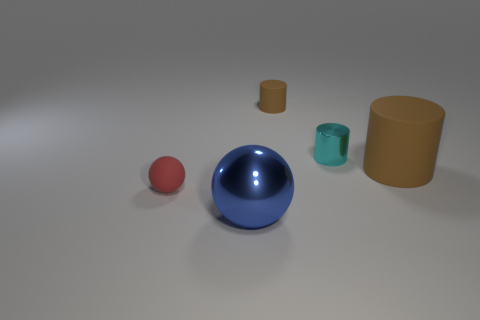Add 1 big brown cylinders. How many objects exist? 6 Subtract 1 balls. How many balls are left? 1 Subtract all cyan cylinders. How many cylinders are left? 2 Subtract all cyan shiny cylinders. How many cylinders are left? 2 Subtract all brown cylinders. How many red balls are left? 1 Subtract all tiny brown matte objects. Subtract all brown matte objects. How many objects are left? 2 Add 1 large brown rubber objects. How many large brown rubber objects are left? 2 Add 3 large yellow metallic cubes. How many large yellow metallic cubes exist? 3 Subtract 0 gray cylinders. How many objects are left? 5 Subtract all cylinders. How many objects are left? 2 